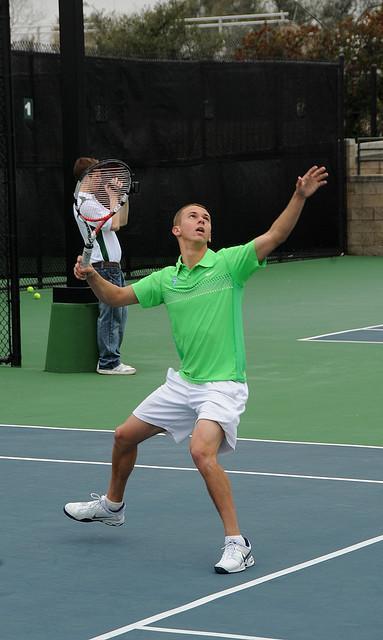How many people are there?
Give a very brief answer. 2. 